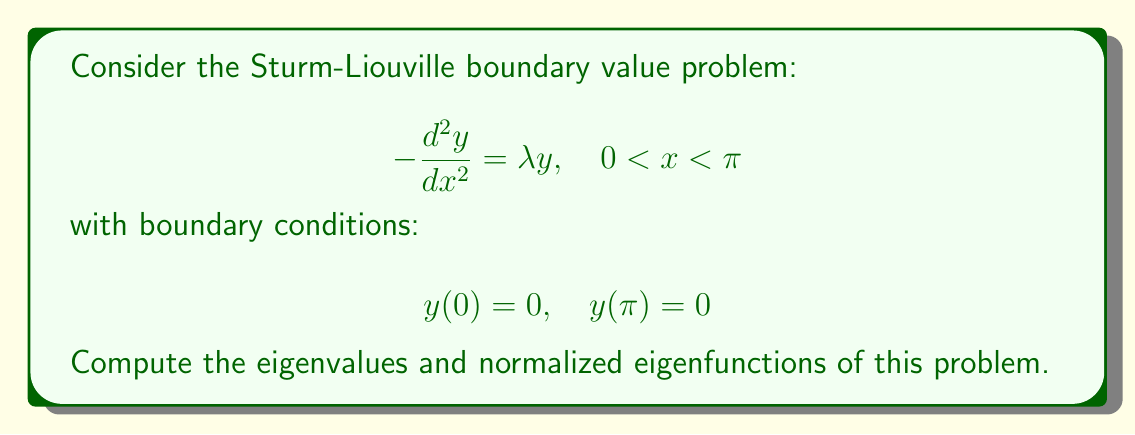Solve this math problem. Let's approach this step-by-step:

1) The general solution to the differential equation is:
   $$y(x) = A \sin(\sqrt{\lambda}x) + B \cos(\sqrt{\lambda}x)$$

2) Applying the boundary condition $y(0) = 0$:
   $$0 = A \sin(0) + B \cos(0) = B$$
   Therefore, $B = 0$ and $y(x) = A \sin(\sqrt{\lambda}x)$

3) Applying the boundary condition $y(\pi) = 0$:
   $$0 = A \sin(\sqrt{\lambda}\pi)$$
   This is satisfied when $\sqrt{\lambda}\pi = n\pi$ for $n = 1, 2, 3, ...$

4) Solving for $\lambda$:
   $$\lambda = n^2, \quad n = 1, 2, 3, ...$$
   These are the eigenvalues.

5) The corresponding eigenfunctions are:
   $$y_n(x) = A_n \sin(nx), \quad n = 1, 2, 3, ...$$

6) To normalize the eigenfunctions, we need:
   $$\int_0^\pi y_n^2(x) dx = 1$$

   $$A_n^2 \int_0^\pi \sin^2(nx) dx = 1$$

   $$A_n^2 \cdot \frac{\pi}{2} = 1$$

   $$A_n = \sqrt{\frac{2}{\pi}}$$

7) Therefore, the normalized eigenfunctions are:
   $$y_n(x) = \sqrt{\frac{2}{\pi}} \sin(nx), \quad n = 1, 2, 3, ...$$
Answer: Eigenvalues: $\lambda_n = n^2$, $n = 1, 2, 3, ...$
Normalized eigenfunctions: $y_n(x) = \sqrt{\frac{2}{\pi}} \sin(nx)$, $n = 1, 2, 3, ...$ 